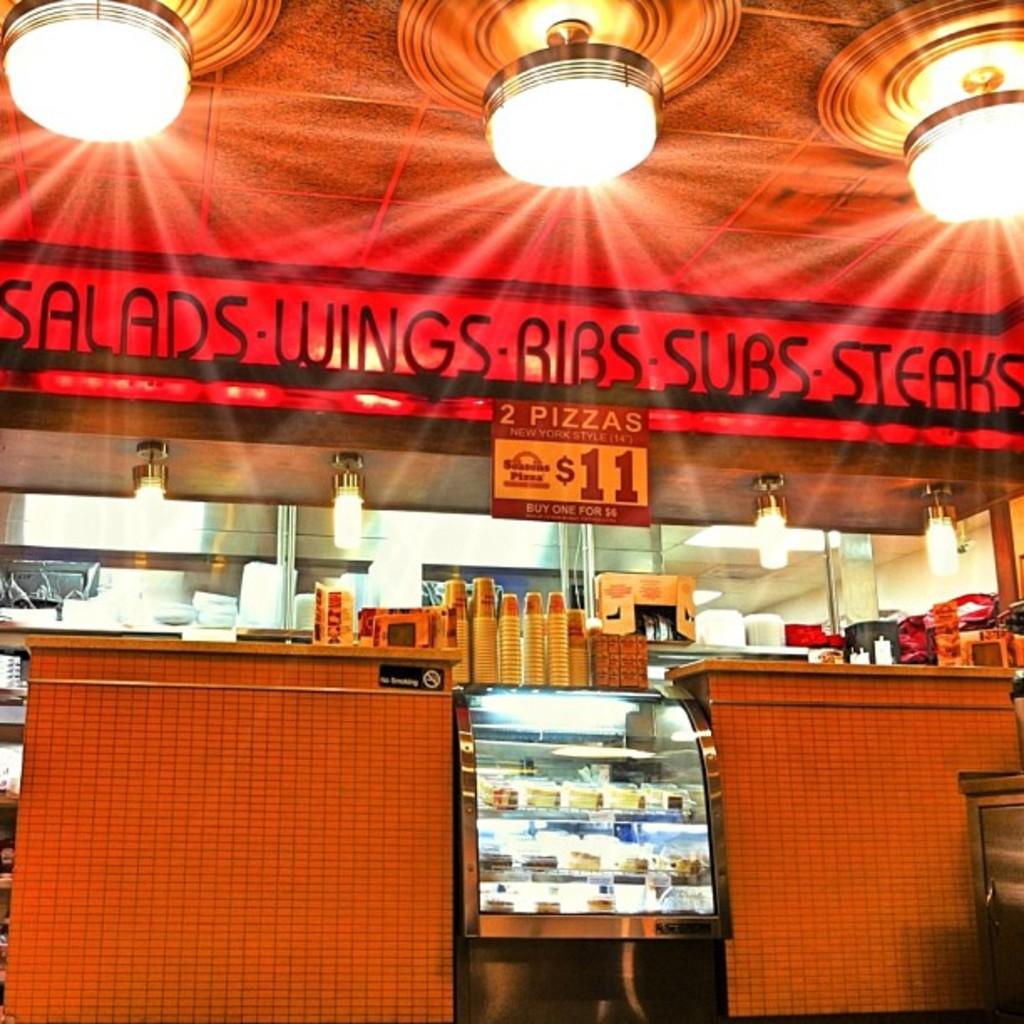What is only $11?
Your answer should be very brief. 2 pizzas. 